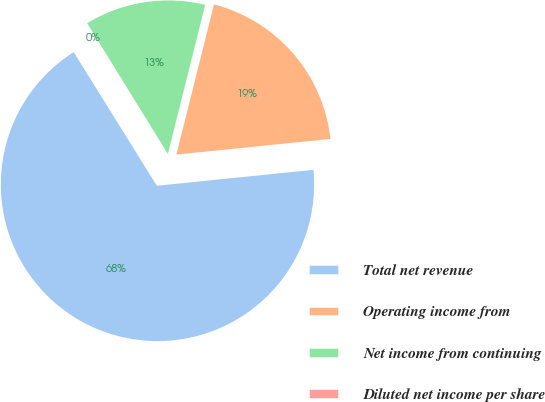Convert chart. <chart><loc_0><loc_0><loc_500><loc_500><pie_chart><fcel>Total net revenue<fcel>Operating income from<fcel>Net income from continuing<fcel>Diluted net income per share<nl><fcel>67.76%<fcel>19.48%<fcel>12.71%<fcel>0.05%<nl></chart> 